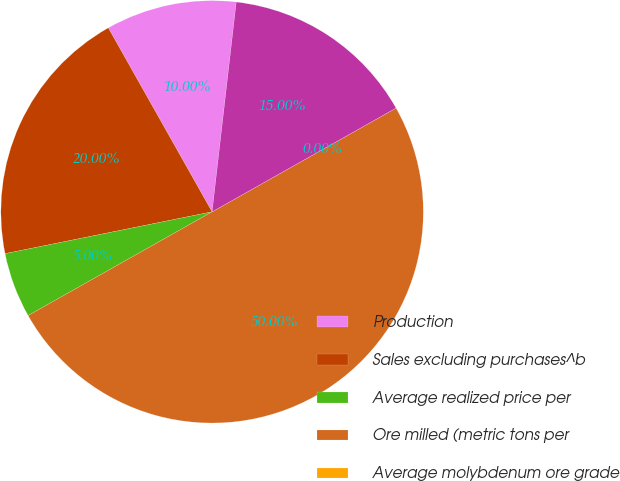Convert chart. <chart><loc_0><loc_0><loc_500><loc_500><pie_chart><fcel>Production<fcel>Sales excluding purchases^b<fcel>Average realized price per<fcel>Ore milled (metric tons per<fcel>Average molybdenum ore grade<fcel>Molybdenum production<nl><fcel>10.0%<fcel>20.0%<fcel>5.0%<fcel>50.0%<fcel>0.0%<fcel>15.0%<nl></chart> 